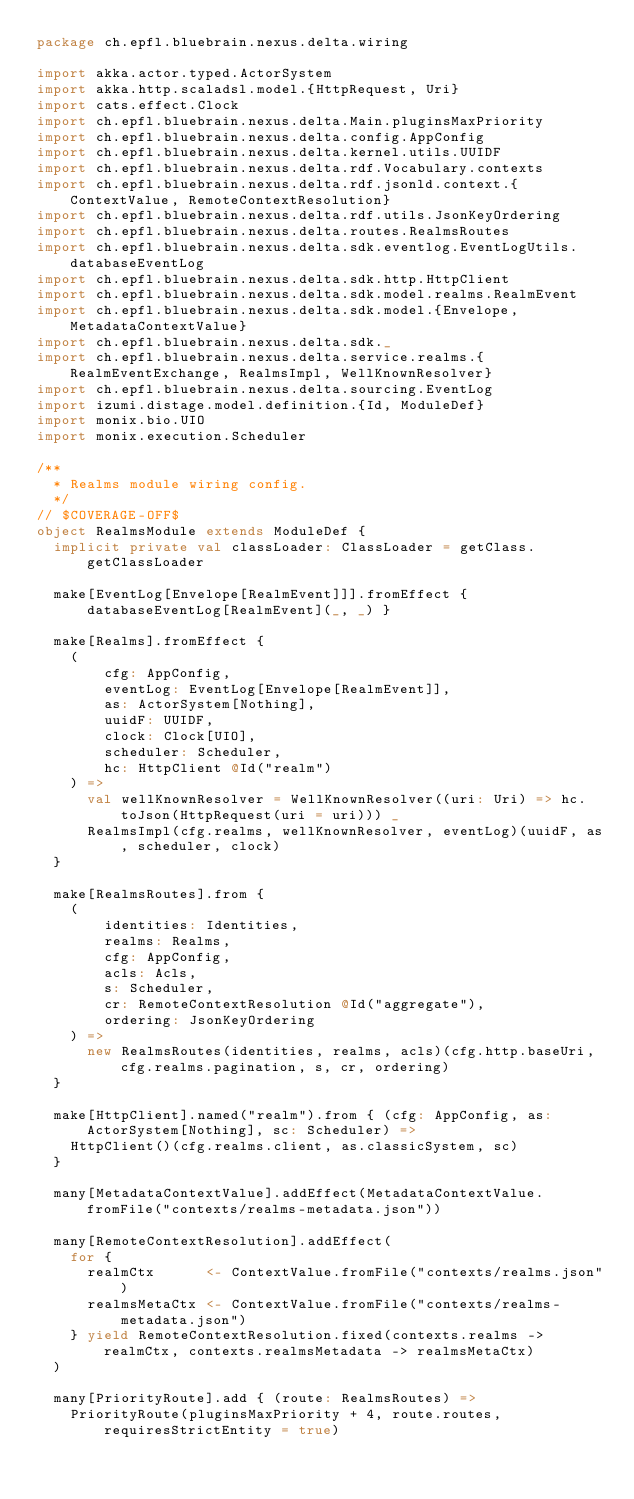<code> <loc_0><loc_0><loc_500><loc_500><_Scala_>package ch.epfl.bluebrain.nexus.delta.wiring

import akka.actor.typed.ActorSystem
import akka.http.scaladsl.model.{HttpRequest, Uri}
import cats.effect.Clock
import ch.epfl.bluebrain.nexus.delta.Main.pluginsMaxPriority
import ch.epfl.bluebrain.nexus.delta.config.AppConfig
import ch.epfl.bluebrain.nexus.delta.kernel.utils.UUIDF
import ch.epfl.bluebrain.nexus.delta.rdf.Vocabulary.contexts
import ch.epfl.bluebrain.nexus.delta.rdf.jsonld.context.{ContextValue, RemoteContextResolution}
import ch.epfl.bluebrain.nexus.delta.rdf.utils.JsonKeyOrdering
import ch.epfl.bluebrain.nexus.delta.routes.RealmsRoutes
import ch.epfl.bluebrain.nexus.delta.sdk.eventlog.EventLogUtils.databaseEventLog
import ch.epfl.bluebrain.nexus.delta.sdk.http.HttpClient
import ch.epfl.bluebrain.nexus.delta.sdk.model.realms.RealmEvent
import ch.epfl.bluebrain.nexus.delta.sdk.model.{Envelope, MetadataContextValue}
import ch.epfl.bluebrain.nexus.delta.sdk._
import ch.epfl.bluebrain.nexus.delta.service.realms.{RealmEventExchange, RealmsImpl, WellKnownResolver}
import ch.epfl.bluebrain.nexus.delta.sourcing.EventLog
import izumi.distage.model.definition.{Id, ModuleDef}
import monix.bio.UIO
import monix.execution.Scheduler

/**
  * Realms module wiring config.
  */
// $COVERAGE-OFF$
object RealmsModule extends ModuleDef {
  implicit private val classLoader: ClassLoader = getClass.getClassLoader

  make[EventLog[Envelope[RealmEvent]]].fromEffect { databaseEventLog[RealmEvent](_, _) }

  make[Realms].fromEffect {
    (
        cfg: AppConfig,
        eventLog: EventLog[Envelope[RealmEvent]],
        as: ActorSystem[Nothing],
        uuidF: UUIDF,
        clock: Clock[UIO],
        scheduler: Scheduler,
        hc: HttpClient @Id("realm")
    ) =>
      val wellKnownResolver = WellKnownResolver((uri: Uri) => hc.toJson(HttpRequest(uri = uri))) _
      RealmsImpl(cfg.realms, wellKnownResolver, eventLog)(uuidF, as, scheduler, clock)
  }

  make[RealmsRoutes].from {
    (
        identities: Identities,
        realms: Realms,
        cfg: AppConfig,
        acls: Acls,
        s: Scheduler,
        cr: RemoteContextResolution @Id("aggregate"),
        ordering: JsonKeyOrdering
    ) =>
      new RealmsRoutes(identities, realms, acls)(cfg.http.baseUri, cfg.realms.pagination, s, cr, ordering)
  }

  make[HttpClient].named("realm").from { (cfg: AppConfig, as: ActorSystem[Nothing], sc: Scheduler) =>
    HttpClient()(cfg.realms.client, as.classicSystem, sc)
  }

  many[MetadataContextValue].addEffect(MetadataContextValue.fromFile("contexts/realms-metadata.json"))

  many[RemoteContextResolution].addEffect(
    for {
      realmCtx      <- ContextValue.fromFile("contexts/realms.json")
      realmsMetaCtx <- ContextValue.fromFile("contexts/realms-metadata.json")
    } yield RemoteContextResolution.fixed(contexts.realms -> realmCtx, contexts.realmsMetadata -> realmsMetaCtx)
  )

  many[PriorityRoute].add { (route: RealmsRoutes) =>
    PriorityRoute(pluginsMaxPriority + 4, route.routes, requiresStrictEntity = true)</code> 